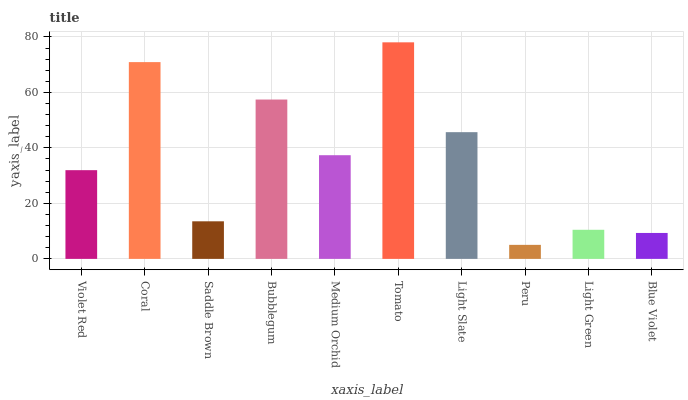Is Peru the minimum?
Answer yes or no. Yes. Is Tomato the maximum?
Answer yes or no. Yes. Is Coral the minimum?
Answer yes or no. No. Is Coral the maximum?
Answer yes or no. No. Is Coral greater than Violet Red?
Answer yes or no. Yes. Is Violet Red less than Coral?
Answer yes or no. Yes. Is Violet Red greater than Coral?
Answer yes or no. No. Is Coral less than Violet Red?
Answer yes or no. No. Is Medium Orchid the high median?
Answer yes or no. Yes. Is Violet Red the low median?
Answer yes or no. Yes. Is Light Slate the high median?
Answer yes or no. No. Is Saddle Brown the low median?
Answer yes or no. No. 